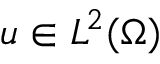Convert formula to latex. <formula><loc_0><loc_0><loc_500><loc_500>u \in L ^ { 2 } ( \Omega )</formula> 